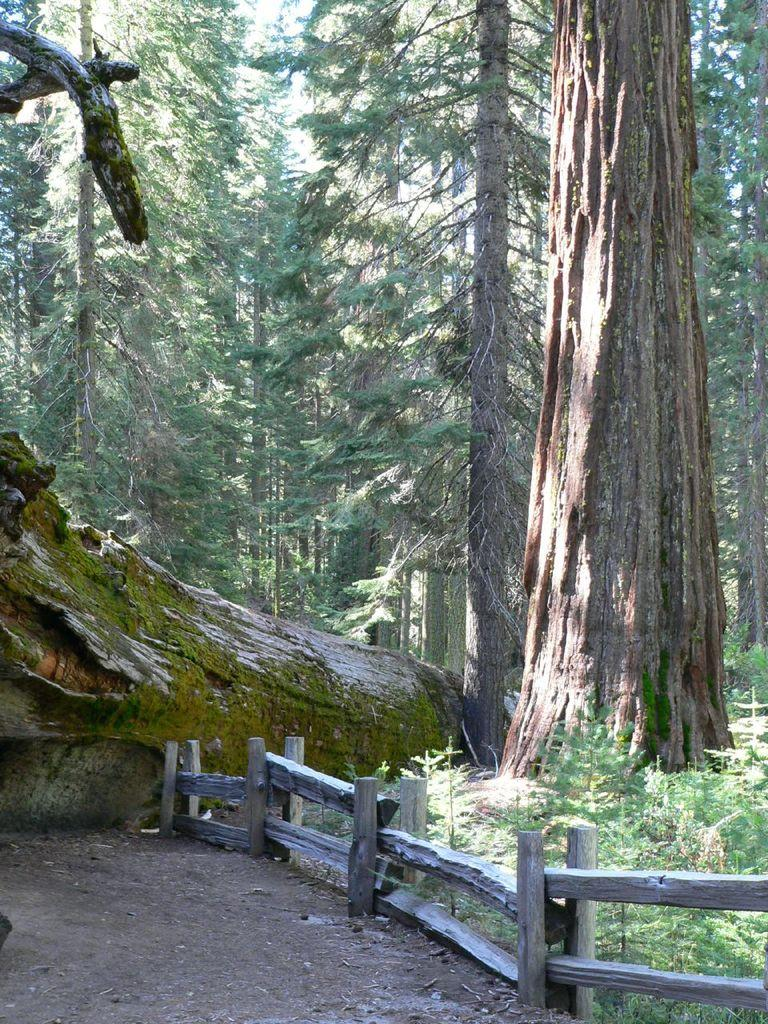What type of structure can be seen in the image? There is a fence in the image. What type of vegetation is present in the image? There are plants and trees in the image. What type of amusement can be seen in the image? There is no amusement present in the image; it features a fence, plants, and trees. Can you spot an owl in the image? There is no owl present in the image. 